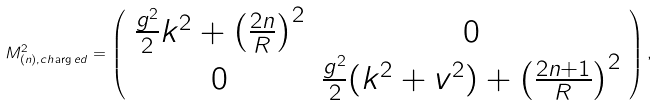Convert formula to latex. <formula><loc_0><loc_0><loc_500><loc_500>M ^ { 2 } _ { ( n ) , c h \arg e d } = \left ( \begin{array} { c c } \frac { g ^ { 2 } } 2 k ^ { 2 } + \left ( \frac { 2 n } R \right ) ^ { 2 } & 0 \\ 0 & \frac { g ^ { 2 } } 2 ( k ^ { 2 } + v ^ { 2 } ) + \left ( \frac { 2 n + 1 } R \right ) ^ { 2 } \end{array} \right ) ,</formula> 